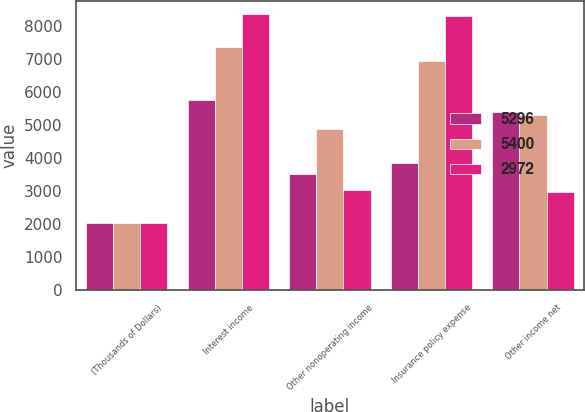Convert chart. <chart><loc_0><loc_0><loc_500><loc_500><stacked_bar_chart><ecel><fcel>(Thousands of Dollars)<fcel>Interest income<fcel>Other nonoperating income<fcel>Insurance policy expense<fcel>Other income net<nl><fcel>5296<fcel>2015<fcel>5737<fcel>3514<fcel>3851<fcel>5400<nl><fcel>5400<fcel>2014<fcel>7353<fcel>4866<fcel>6923<fcel>5296<nl><fcel>2972<fcel>2013<fcel>8343<fcel>3025<fcel>8292<fcel>2972<nl></chart> 